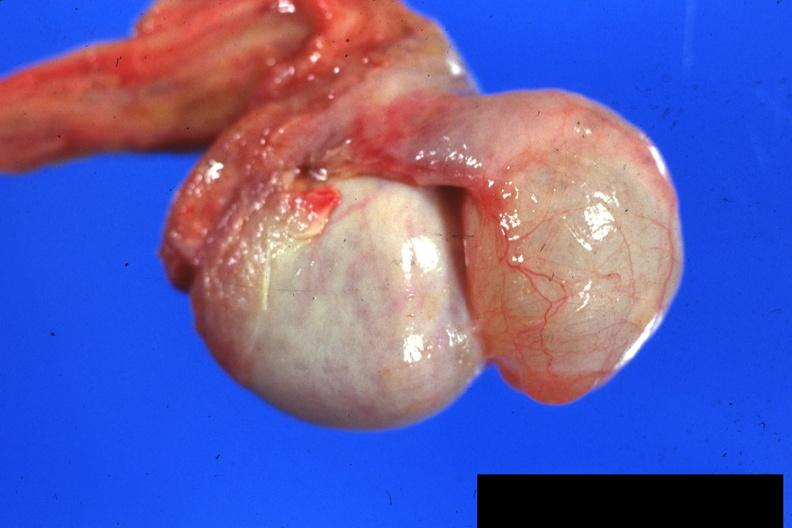what is present?
Answer the question using a single word or phrase. Testicle 